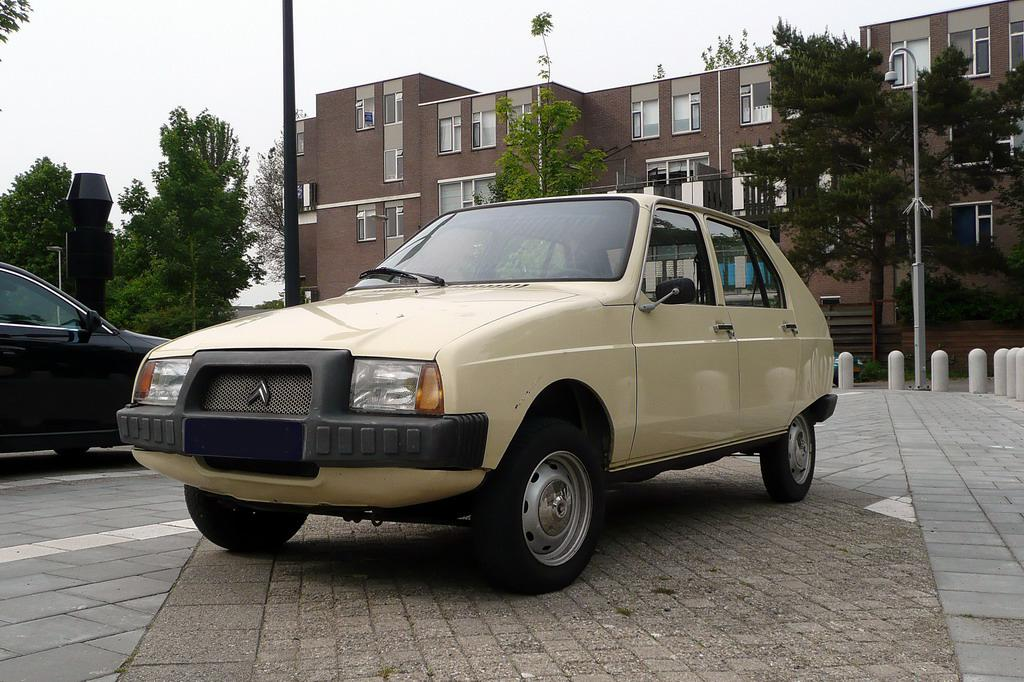What type of vehicles can be seen in the image? There are cars in the image. What surface are the cars on? The cars are on tiles. What other objects are present in the image? There are poles, a light, trees, and a building in the image. What can be seen in the background of the image? The sky is visible in the background of the image. What is the tendency of the giants in the image? There are no giants present in the image. How many nails are used to hold the light in the image? There is no mention of nails in the image; the light is simply present. 